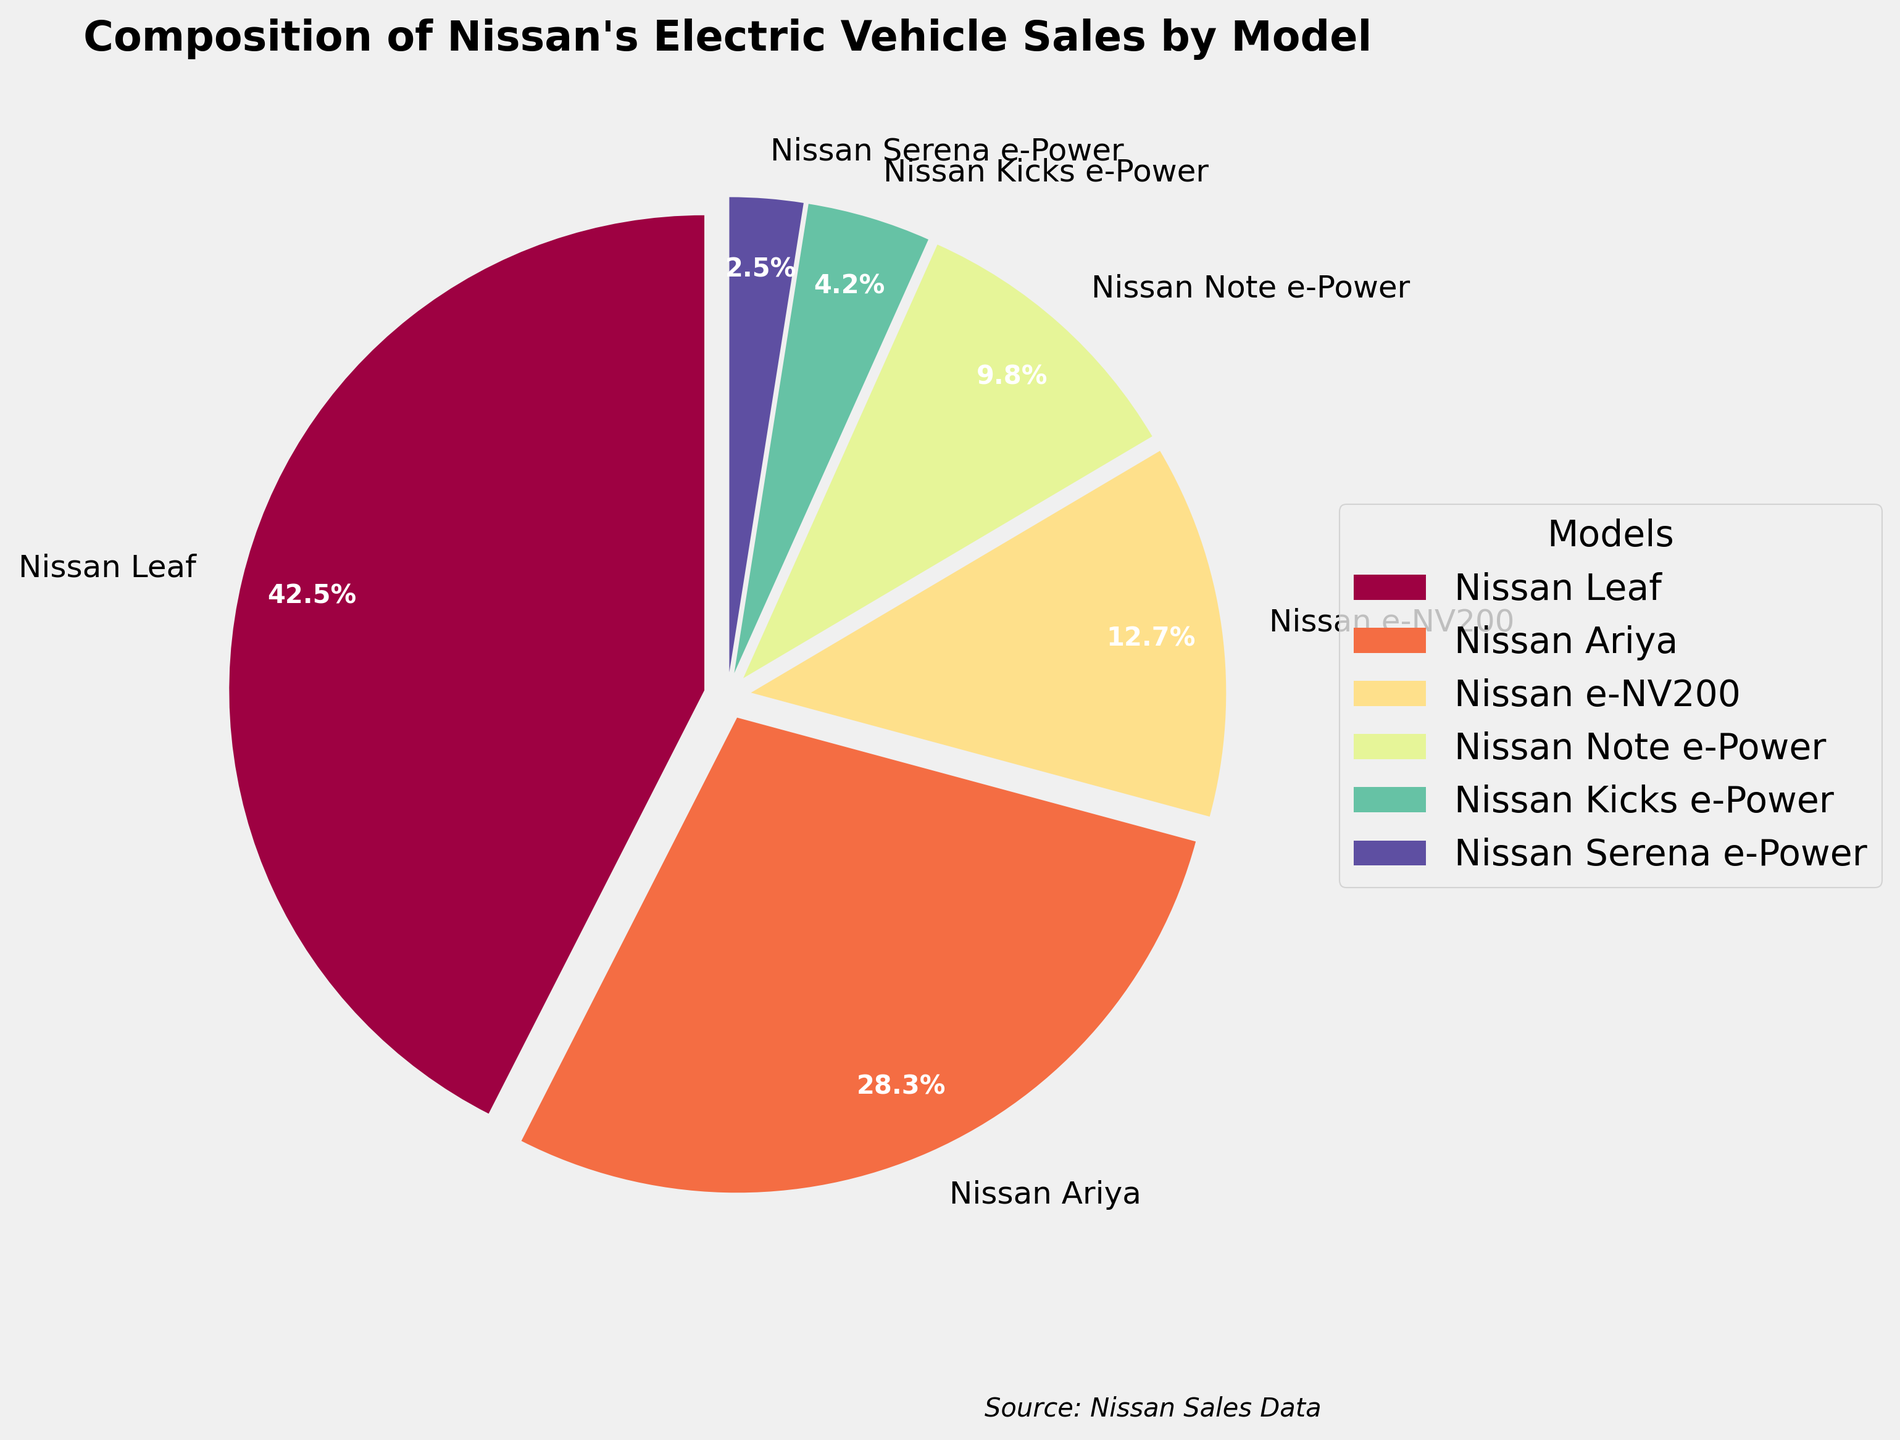Which model has the highest percentage of sales? By looking at the pie chart, the Nissan Leaf has the largest wedge and also the highest percentage indicated on the chart, which is 42.5%.
Answer: Nissan Leaf How much more sales percentage does the Nissan Leaf have over the Nissan Ariya? The Nissan Leaf has 42.5% of the sales while the Nissan Ariya has 28.3%. The difference can be calculated as 42.5% - 28.3% = 14.2%.
Answer: 14.2% What is the combined percentage of sales for the Nissan e-NV200 and Nissan Note e-Power? By looking at the pie chart, the Nissan e-NV200 has 12.7% and the Nissan Note e-Power has 9.8%. Combined, this is 12.7% + 9.8% = 22.5%.
Answer: 22.5% Which model has the smallest percentage of sales? By observing the chart, the smallest wedge and percentage corresponds to the Nissan Serena e-Power, which has 2.5% of the sales.
Answer: Nissan Serena e-Power Does the Nissan Kicks e-Power have more or less sales compared to the Nissan Note e-Power? The pie chart shows that the Nissan Kicks e-Power has 4.2% of the sales while the Nissan Note e-Power has 9.8%, meaning the Kicks e-Power has less.
Answer: Less What is the total percentage of sales for models with the word 'e-Power' in their name? The models with 'e-Power' in their name are Nissan Note e-Power (9.8%), Nissan Kicks e-Power (4.2%), and Nissan Serena e-Power (2.5%). The combined percentage is 9.8% + 4.2% + 2.5% = 16.5%.
Answer: 16.5% What's the average percentage of sales for the top three models? The top three models are Nissan Leaf (42.5%), Nissan Ariya (28.3%), and Nissan e-NV200 (12.7%). The average percentage can be calculated as (42.5% + 28.3% + 12.7%) / 3 = 83.5% / 3 ≈ 27.83%.
Answer: 27.83% How much more percentage does the Nissan Leaf have over the combined sales percentage of the Nissan Kicks e-Power and Nissan Serena e-Power? The Nissan Leaf has 42.5% of the sales. Nissan Kicks e-Power has 4.2% and Nissan Serena e-Power has 2.5%, and combined they make up 4.2% + 2.5% = 6.7%. The difference is 42.5% - 6.7% = 35.8%.
Answer: 35.8% What is the visual representation (color) of the Nissan Leaf in the chart? By looking at the chart, we can identify the color associated with the largest wedge, which represents the Nissan Leaf. In this particular plot, the Nissan Leaf is represented with the color typically at the beginning of the color palette (often a red or orange tone).
Answer: Red/Orange (depending on the specific colormap settings) Is the percentage of the Nissan Note e-Power more than double that of the Nissan Kicks e-Power? The Nissan Note e-Power has 9.8% while the Nissan Kicks e-Power has 4.2%. To determine if Note e-Power's percentage is more than double, we calculate 4.2% * 2 = 8.4%. Since 9.8% is greater than 8.4%, the answer is yes.
Answer: Yes 